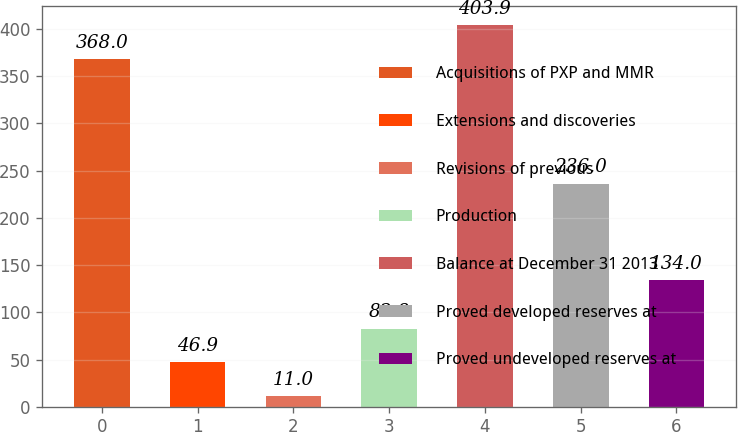Convert chart. <chart><loc_0><loc_0><loc_500><loc_500><bar_chart><fcel>Acquisitions of PXP and MMR<fcel>Extensions and discoveries<fcel>Revisions of previous<fcel>Production<fcel>Balance at December 31 2013<fcel>Proved developed reserves at<fcel>Proved undeveloped reserves at<nl><fcel>368<fcel>46.9<fcel>11<fcel>82.8<fcel>403.9<fcel>236<fcel>134<nl></chart> 